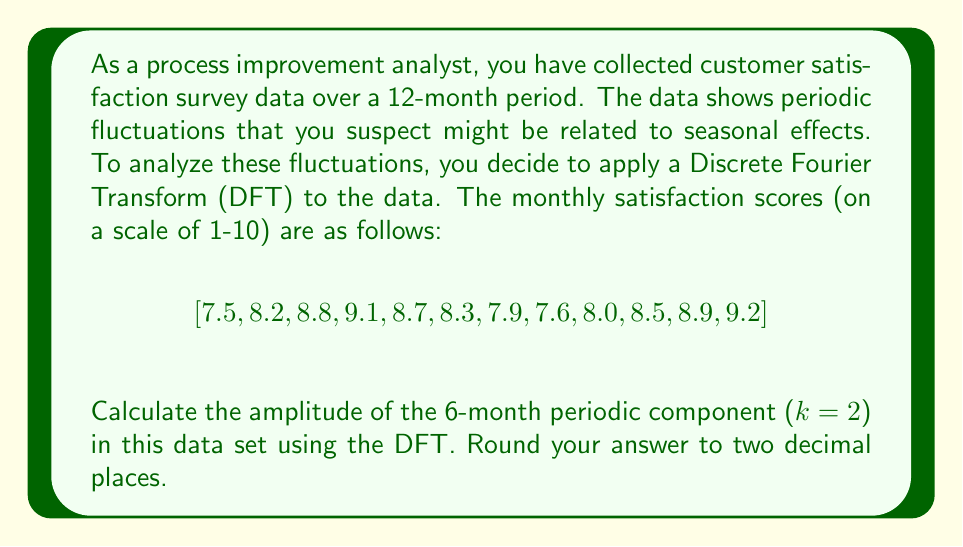Help me with this question. To solve this problem, we'll follow these steps:

1) The Discrete Fourier Transform (DFT) for a sequence $x[n]$ of length N is given by:

   $$X[k] = \sum_{n=0}^{N-1} x[n] e^{-i2\pi kn/N}$$

2) For the 6-month periodic component, k = 2 (as the fundamental frequency corresponds to k = 1, which is a 12-month cycle).

3) We have N = 12 data points. Let's calculate $X[2]$:

   $$X[2] = \sum_{n=0}^{11} x[n] e^{-i2\pi (2)n/12}$$

4) Expanding this:

   $$X[2] = 7.5e^{-i\pi/3} + 8.2e^{-i2\pi/3} + 8.8e^{-i\pi} + 9.1e^{-i4\pi/3} + 8.7e^{-i5\pi/3} + 8.3e^{-i2\pi} + \\
   7.9e^{-i7\pi/3} + 7.6e^{-i8\pi/3} + 8.0e^{-i3\pi} + 8.5e^{-i10\pi/3} + 8.9e^{-i11\pi/3} + 9.2e^{-i4\pi}$$

5) Calculating this (you would typically use software for this step):

   $X[2] \approx -0.3 - 0.5196i$

6) The amplitude of this component is given by the magnitude of $X[2]$:

   $$|X[2]| = \sqrt{(-0.3)^2 + (-0.5196)^2} \approx 0.60$$

7) However, to get the true amplitude, we need to divide this by N/2 = 6:

   $$\text{Amplitude} = \frac{|X[2]|}{6} \approx 0.10$$
Answer: 0.10 